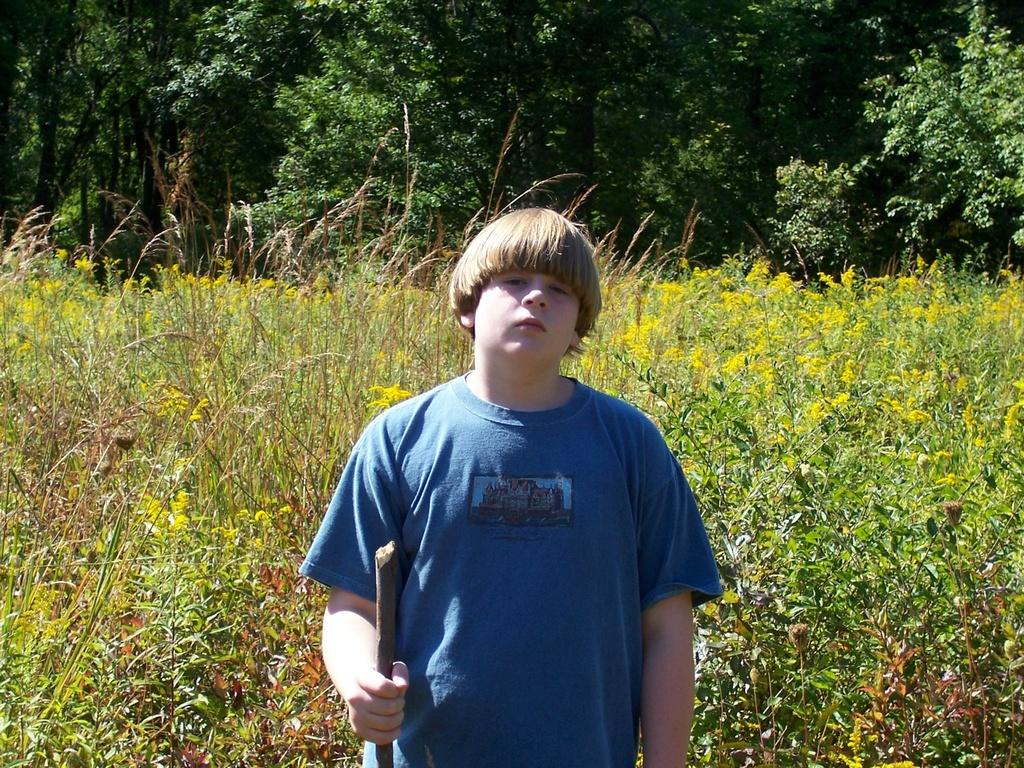What is the main subject of the image? There is a person in the image. What is the person holding in the image? The person is holding a stick. What can be seen in the background of the image? There are plants and trees in the background of the image. What type of lettuce is being used to hit the ice in the image? There is no lettuce or ice present in the image. What tool is the person using to hammer the hammer in the image? There is no hammer present in the image; the person is holding a stick. 